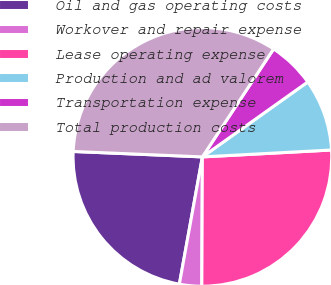<chart> <loc_0><loc_0><loc_500><loc_500><pie_chart><fcel>Oil and gas operating costs<fcel>Workover and repair expense<fcel>Lease operating expense<fcel>Production and ad valorem<fcel>Transportation expense<fcel>Total production costs<nl><fcel>22.82%<fcel>2.78%<fcel>25.92%<fcel>8.99%<fcel>5.88%<fcel>33.61%<nl></chart> 